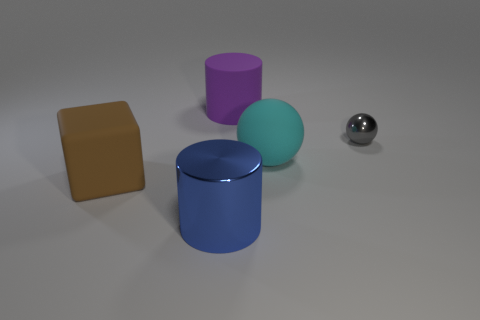Add 1 small gray shiny spheres. How many objects exist? 6 Subtract all cylinders. How many objects are left? 3 Add 2 small green things. How many small green things exist? 2 Subtract 0 green spheres. How many objects are left? 5 Subtract all tiny brown spheres. Subtract all big cyan balls. How many objects are left? 4 Add 1 metal balls. How many metal balls are left? 2 